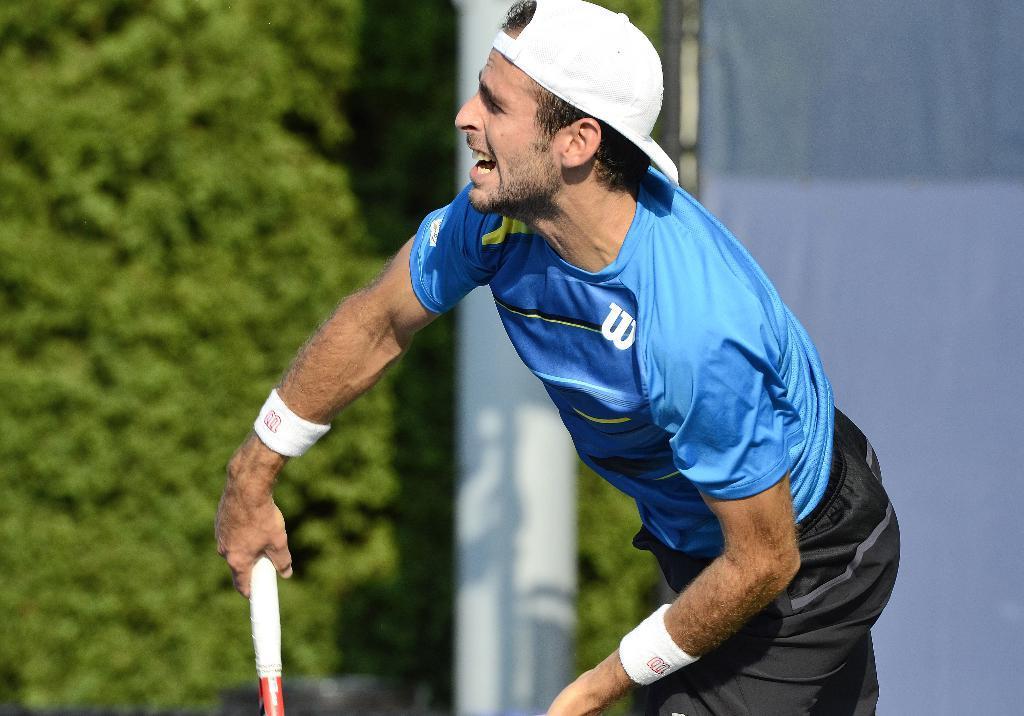How would you summarize this image in a sentence or two? In this image there is a man with hat is standing and holding an object , and there is blur background. 